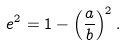Convert formula to latex. <formula><loc_0><loc_0><loc_500><loc_500>e ^ { 2 } = 1 - \left ( \frac { a } { b } \right ) ^ { 2 } .</formula> 